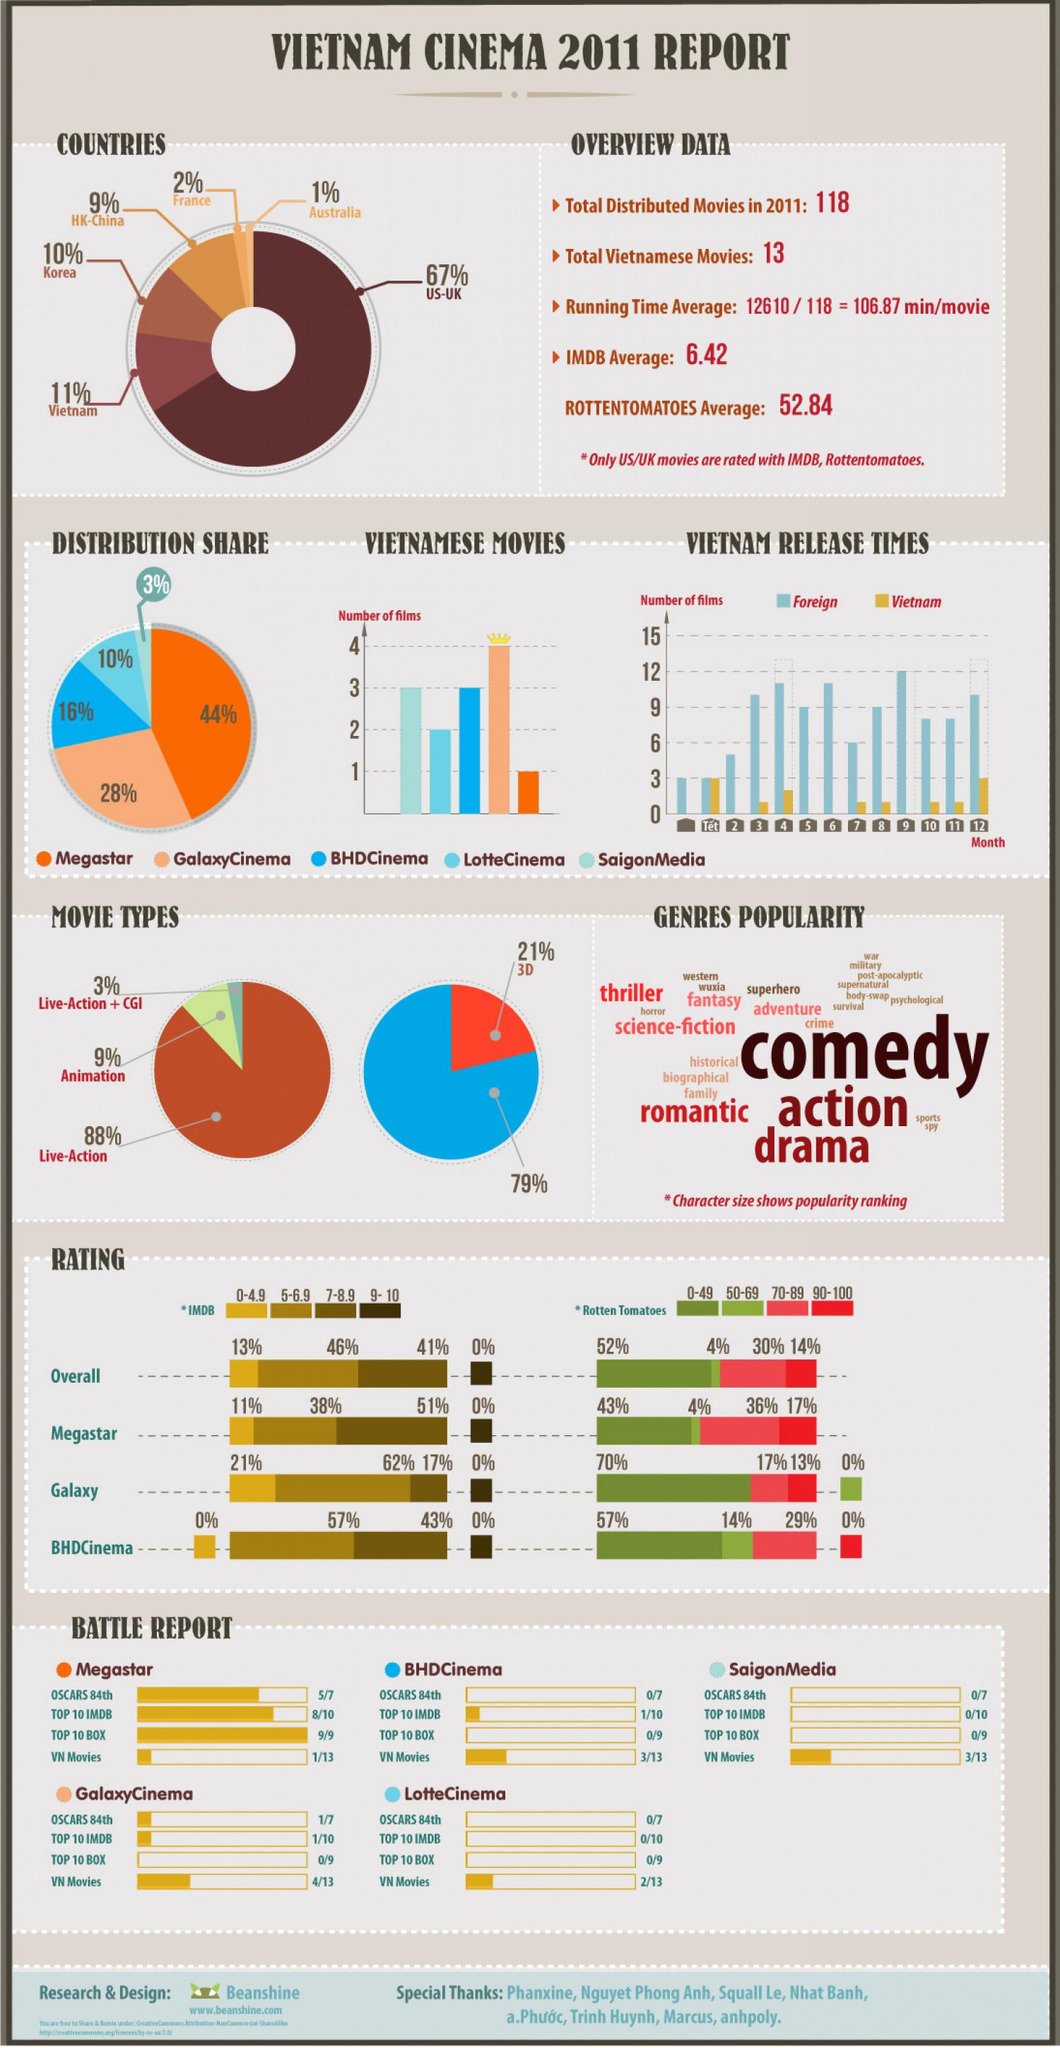Give some essential details in this illustration. According to the data, only 21% of the movies are in 3D. Out of BHD cinema and Megastar distributors, only two have less than three films in their portfolio. How many bullet points are there under "overview data"? There are 4 of them. Si se puede contar que el 67% de los películas provienen de los Estados Unidos y el Reino Unido. Australia has distributed the least number of movies. 